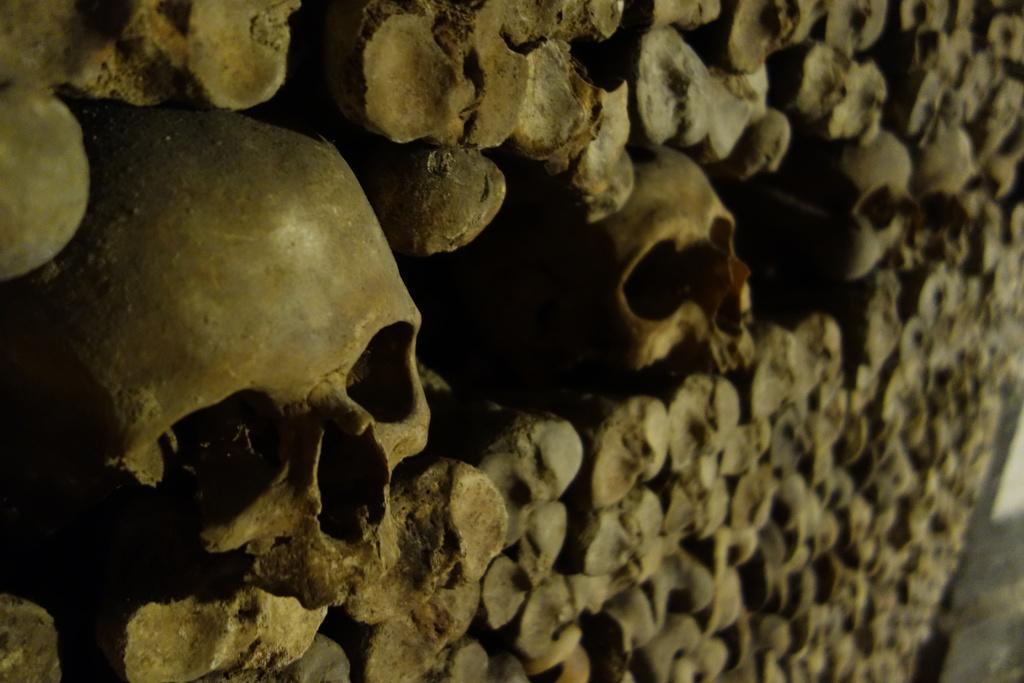Please provide a concise description of this image. In the center of the image we can see the wall,which is made up of human skulls and bones. 